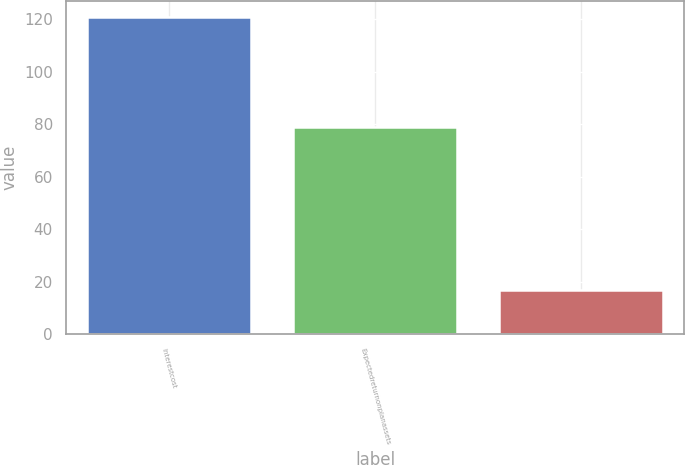<chart> <loc_0><loc_0><loc_500><loc_500><bar_chart><fcel>Interestcost<fcel>Expectedreturnonplanassets<fcel>Unnamed: 2<nl><fcel>121<fcel>79<fcel>17<nl></chart> 